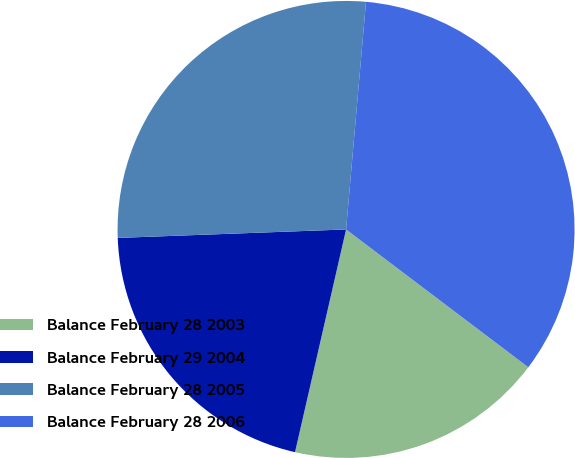Convert chart to OTSL. <chart><loc_0><loc_0><loc_500><loc_500><pie_chart><fcel>Balance February 28 2003<fcel>Balance February 29 2004<fcel>Balance February 28 2005<fcel>Balance February 28 2006<nl><fcel>18.28%<fcel>20.82%<fcel>26.98%<fcel>33.91%<nl></chart> 